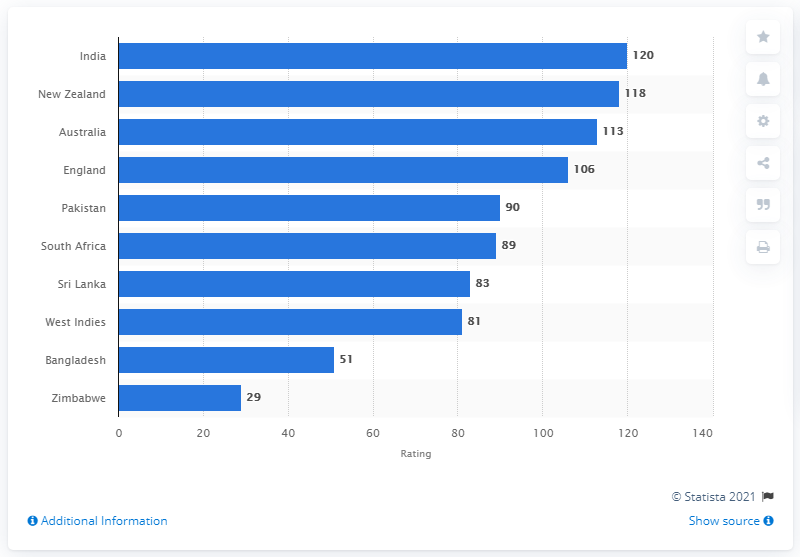List a handful of essential elements in this visual. India is currently at the top of the ICC's test nations list. 